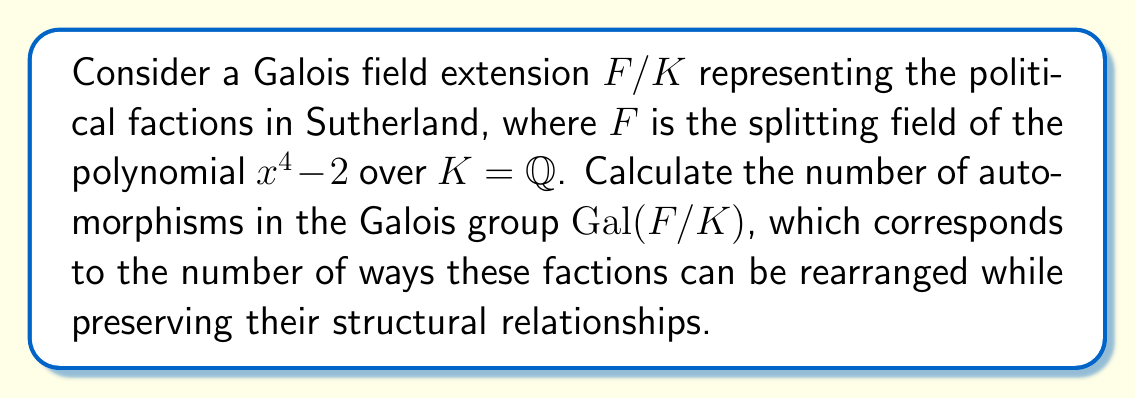Show me your answer to this math problem. To solve this problem, we'll follow these steps:

1) First, we need to identify the splitting field $F$. The polynomial $x^4 - 2$ splits over $\mathbb{Q}(\sqrt[4]{2}, i)$, so $F = \mathbb{Q}(\sqrt[4]{2}, i)$.

2) The degree of this extension is:
   $$[F:K] = [\mathbb{Q}(\sqrt[4]{2}, i) : \mathbb{Q}] = 8$$

   This is because $[\mathbb{Q}(\sqrt[4]{2}) : \mathbb{Q}] = 4$ and $[\mathbb{Q}(\sqrt[4]{2}, i) : \mathbb{Q}(\sqrt[4]{2})] = 2$.

3) For a Galois extension, the order of the Galois group is equal to the degree of the extension. Therefore:
   $$|Gal(F/K)| = [F:K] = 8$$

4) The Galois group $Gal(F/K)$ is isomorphic to the dihedral group $D_4$ of order 8.

5) The number of automorphisms in the Galois group is equal to its order.

Therefore, the number of automorphisms in the Galois group, representing the number of ways the political factions in Sutherland can be rearranged while preserving their structural relationships, is 8.
Answer: 8 